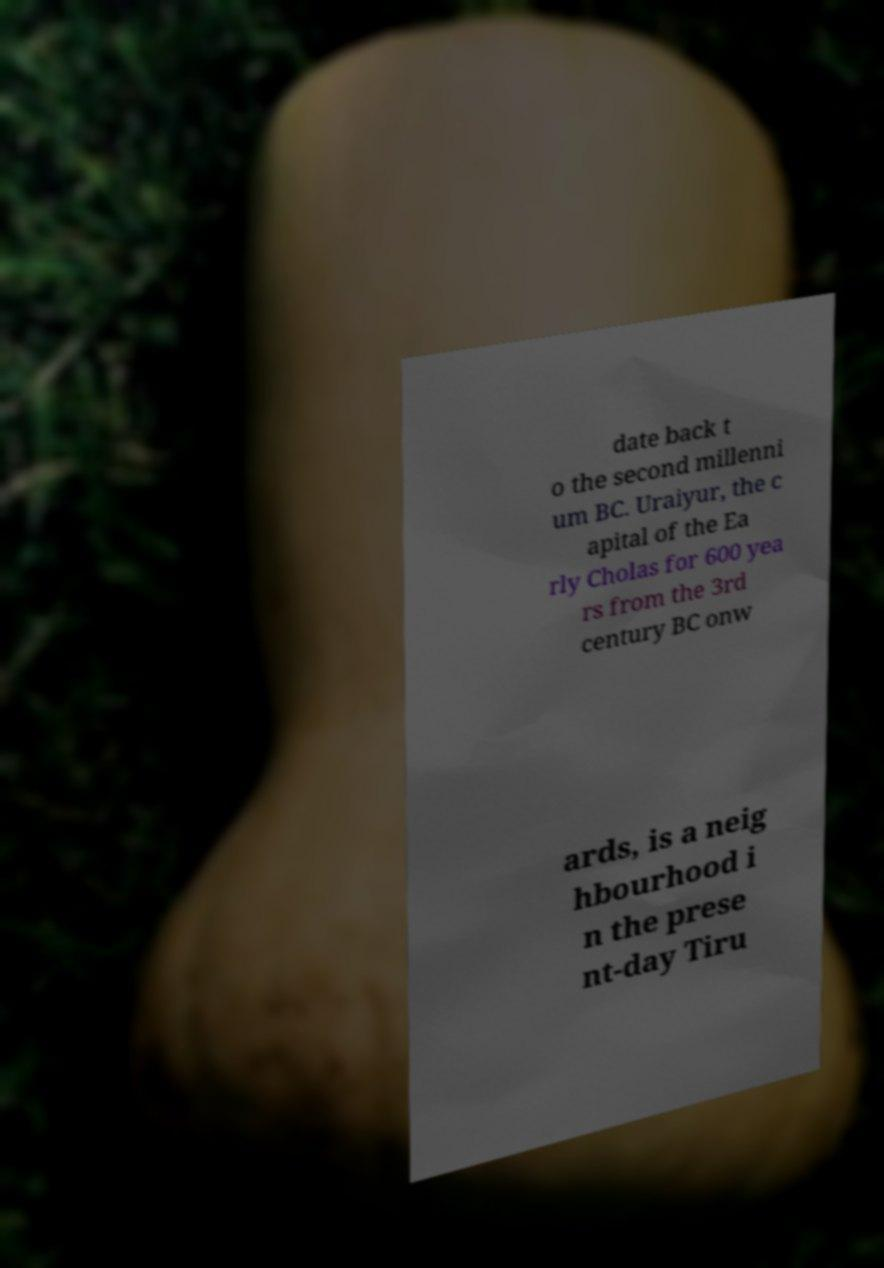There's text embedded in this image that I need extracted. Can you transcribe it verbatim? date back t o the second millenni um BC. Uraiyur, the c apital of the Ea rly Cholas for 600 yea rs from the 3rd century BC onw ards, is a neig hbourhood i n the prese nt-day Tiru 